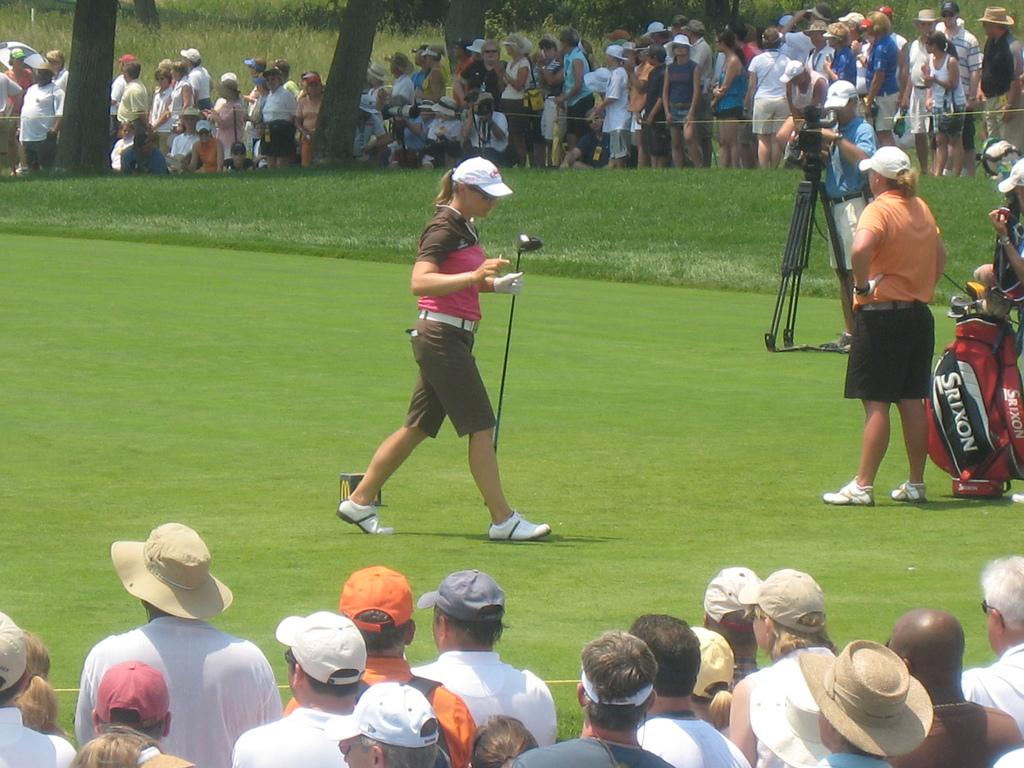What game are people watching?
Provide a short and direct response. Answering does not require reading text in the image. 